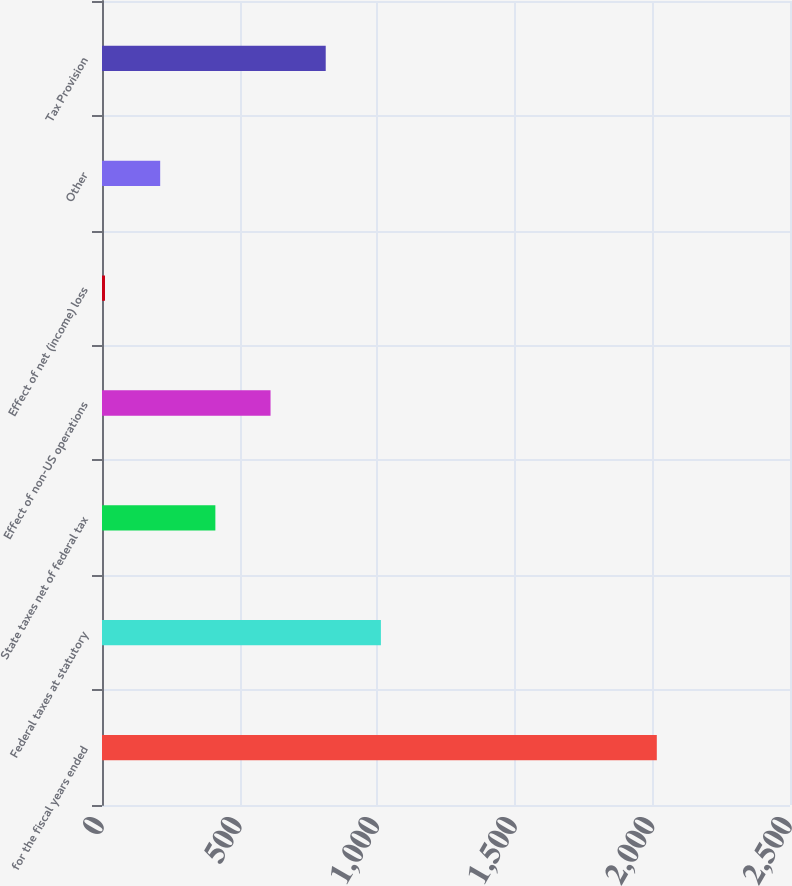Convert chart to OTSL. <chart><loc_0><loc_0><loc_500><loc_500><bar_chart><fcel>for the fiscal years ended<fcel>Federal taxes at statutory<fcel>State taxes net of federal tax<fcel>Effect of non-US operations<fcel>Effect of net (income) loss<fcel>Other<fcel>Tax Provision<nl><fcel>2016<fcel>1013.45<fcel>411.92<fcel>612.43<fcel>10.9<fcel>211.41<fcel>812.94<nl></chart> 